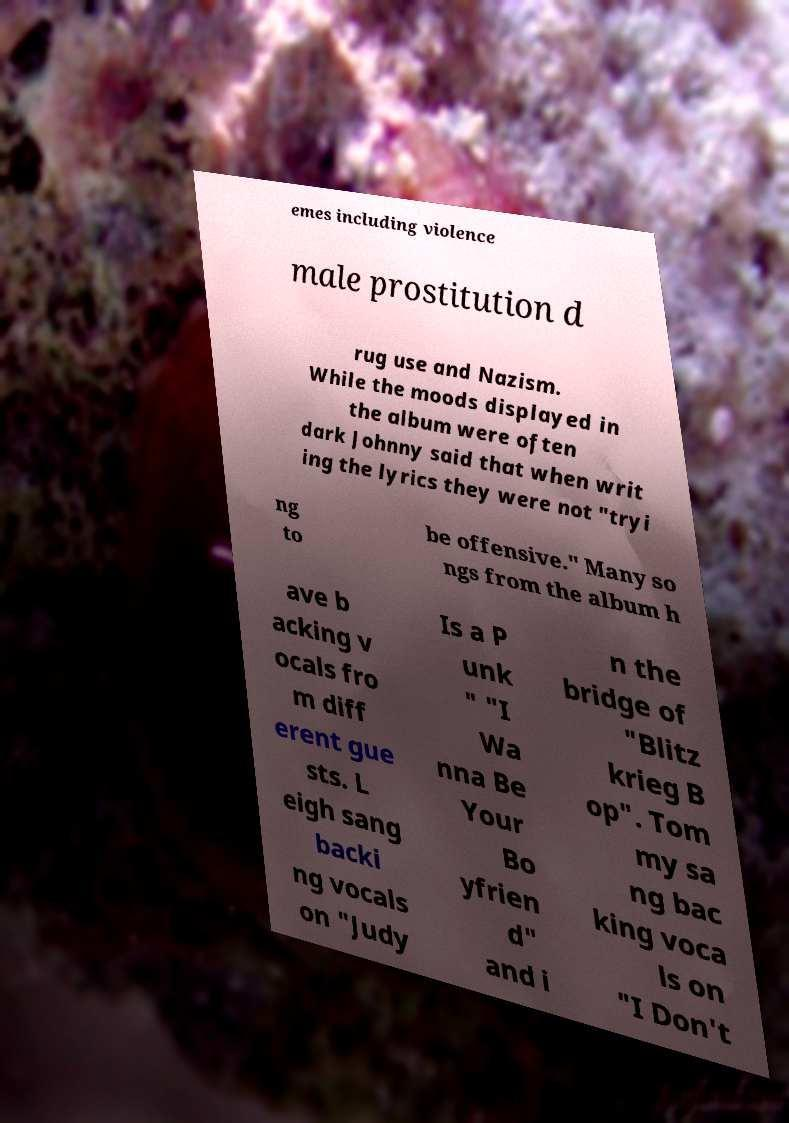I need the written content from this picture converted into text. Can you do that? emes including violence male prostitution d rug use and Nazism. While the moods displayed in the album were often dark Johnny said that when writ ing the lyrics they were not "tryi ng to be offensive." Many so ngs from the album h ave b acking v ocals fro m diff erent gue sts. L eigh sang backi ng vocals on "Judy Is a P unk " "I Wa nna Be Your Bo yfrien d" and i n the bridge of "Blitz krieg B op". Tom my sa ng bac king voca ls on "I Don't 